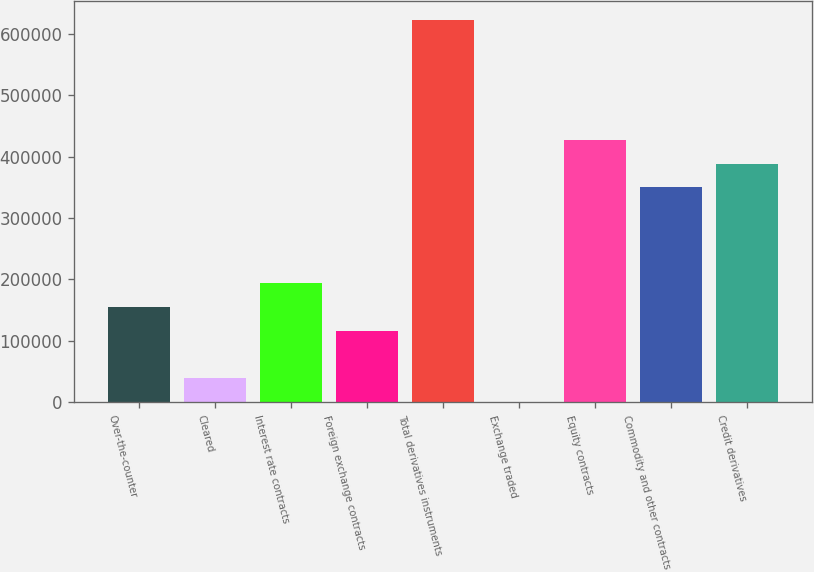<chart> <loc_0><loc_0><loc_500><loc_500><bar_chart><fcel>Over-the-counter<fcel>Cleared<fcel>Interest rate contracts<fcel>Foreign exchange contracts<fcel>Total derivatives instruments<fcel>Exchange traded<fcel>Equity contracts<fcel>Commodity and other contracts<fcel>Credit derivatives<nl><fcel>155486<fcel>38947.9<fcel>194332<fcel>116640<fcel>621636<fcel>102<fcel>427407<fcel>349715<fcel>388561<nl></chart> 